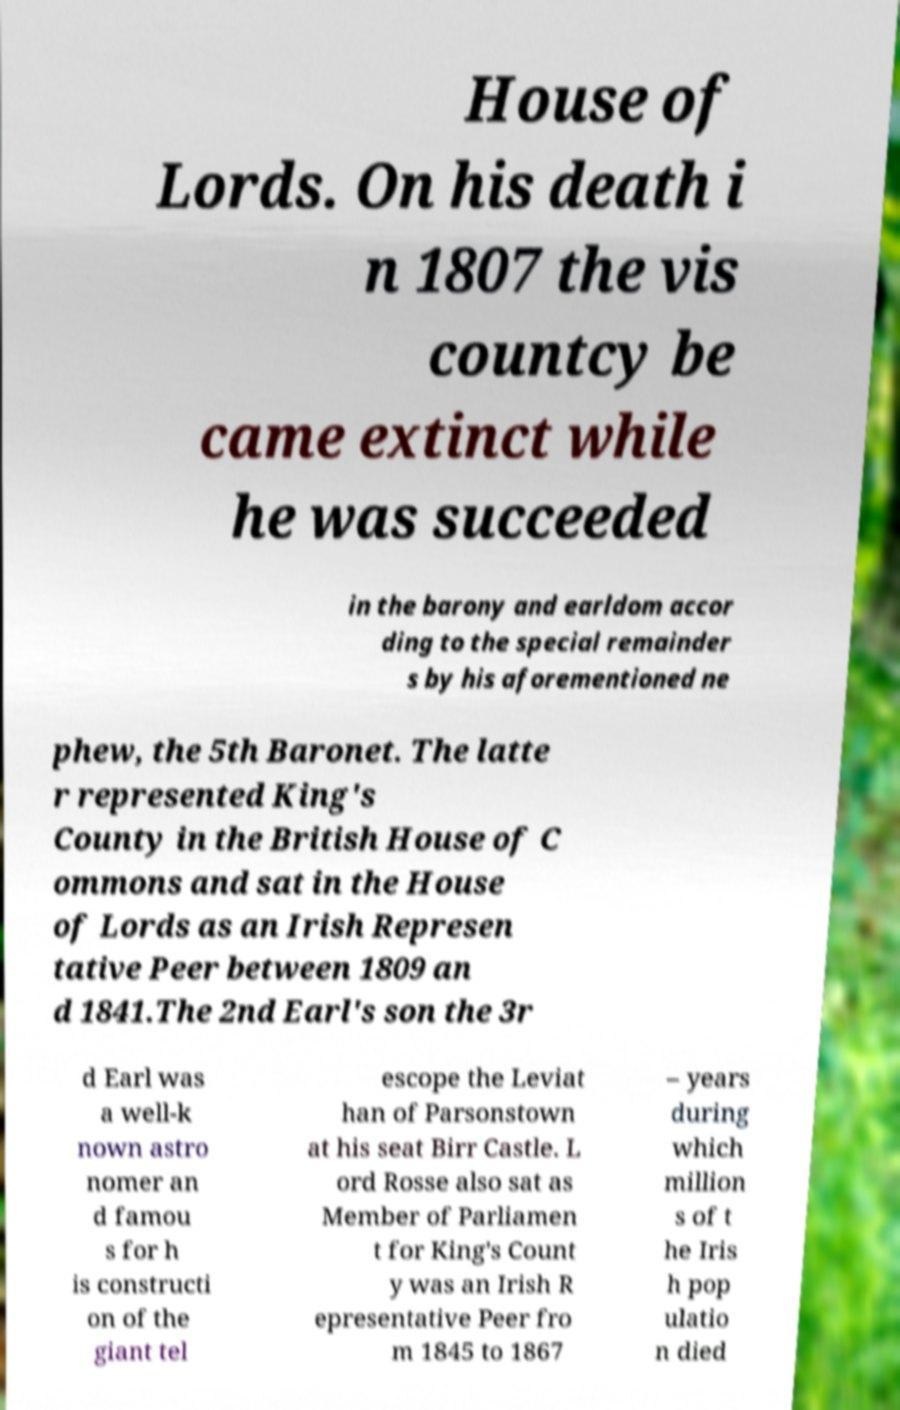I need the written content from this picture converted into text. Can you do that? House of Lords. On his death i n 1807 the vis countcy be came extinct while he was succeeded in the barony and earldom accor ding to the special remainder s by his aforementioned ne phew, the 5th Baronet. The latte r represented King's County in the British House of C ommons and sat in the House of Lords as an Irish Represen tative Peer between 1809 an d 1841.The 2nd Earl's son the 3r d Earl was a well-k nown astro nomer an d famou s for h is constructi on of the giant tel escope the Leviat han of Parsonstown at his seat Birr Castle. L ord Rosse also sat as Member of Parliamen t for King's Count y was an Irish R epresentative Peer fro m 1845 to 1867 – years during which million s of t he Iris h pop ulatio n died 